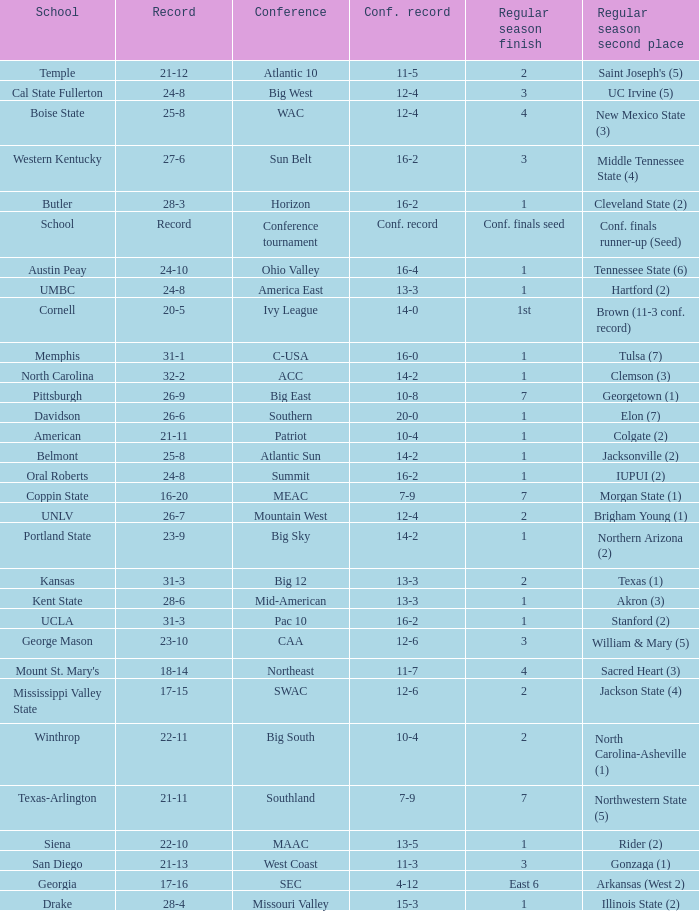For teams in the Sun Belt conference, what is the conference record? 16-2. Would you be able to parse every entry in this table? {'header': ['School', 'Record', 'Conference', 'Conf. record', 'Regular season finish', 'Regular season second place'], 'rows': [['Temple', '21-12', 'Atlantic 10', '11-5', '2', "Saint Joseph's (5)"], ['Cal State Fullerton', '24-8', 'Big West', '12-4', '3', 'UC Irvine (5)'], ['Boise State', '25-8', 'WAC', '12-4', '4', 'New Mexico State (3)'], ['Western Kentucky', '27-6', 'Sun Belt', '16-2', '3', 'Middle Tennessee State (4)'], ['Butler', '28-3', 'Horizon', '16-2', '1', 'Cleveland State (2)'], ['School', 'Record', 'Conference tournament', 'Conf. record', 'Conf. finals seed', 'Conf. finals runner-up (Seed)'], ['Austin Peay', '24-10', 'Ohio Valley', '16-4', '1', 'Tennessee State (6)'], ['UMBC', '24-8', 'America East', '13-3', '1', 'Hartford (2)'], ['Cornell', '20-5', 'Ivy League', '14-0', '1st', 'Brown (11-3 conf. record)'], ['Memphis', '31-1', 'C-USA', '16-0', '1', 'Tulsa (7)'], ['North Carolina', '32-2', 'ACC', '14-2', '1', 'Clemson (3)'], ['Pittsburgh', '26-9', 'Big East', '10-8', '7', 'Georgetown (1)'], ['Davidson', '26-6', 'Southern', '20-0', '1', 'Elon (7)'], ['American', '21-11', 'Patriot', '10-4', '1', 'Colgate (2)'], ['Belmont', '25-8', 'Atlantic Sun', '14-2', '1', 'Jacksonville (2)'], ['Oral Roberts', '24-8', 'Summit', '16-2', '1', 'IUPUI (2)'], ['Coppin State', '16-20', 'MEAC', '7-9', '7', 'Morgan State (1)'], ['UNLV', '26-7', 'Mountain West', '12-4', '2', 'Brigham Young (1)'], ['Portland State', '23-9', 'Big Sky', '14-2', '1', 'Northern Arizona (2)'], ['Kansas', '31-3', 'Big 12', '13-3', '2', 'Texas (1)'], ['Kent State', '28-6', 'Mid-American', '13-3', '1', 'Akron (3)'], ['UCLA', '31-3', 'Pac 10', '16-2', '1', 'Stanford (2)'], ['George Mason', '23-10', 'CAA', '12-6', '3', 'William & Mary (5)'], ["Mount St. Mary's", '18-14', 'Northeast', '11-7', '4', 'Sacred Heart (3)'], ['Mississippi Valley State', '17-15', 'SWAC', '12-6', '2', 'Jackson State (4)'], ['Winthrop', '22-11', 'Big South', '10-4', '2', 'North Carolina-Asheville (1)'], ['Texas-Arlington', '21-11', 'Southland', '7-9', '7', 'Northwestern State (5)'], ['Siena', '22-10', 'MAAC', '13-5', '1', 'Rider (2)'], ['San Diego', '21-13', 'West Coast', '11-3', '3', 'Gonzaga (1)'], ['Georgia', '17-16', 'SEC', '4-12', 'East 6', 'Arkansas (West 2)'], ['Drake', '28-4', 'Missouri Valley', '15-3', '1', 'Illinois State (2)']]} 